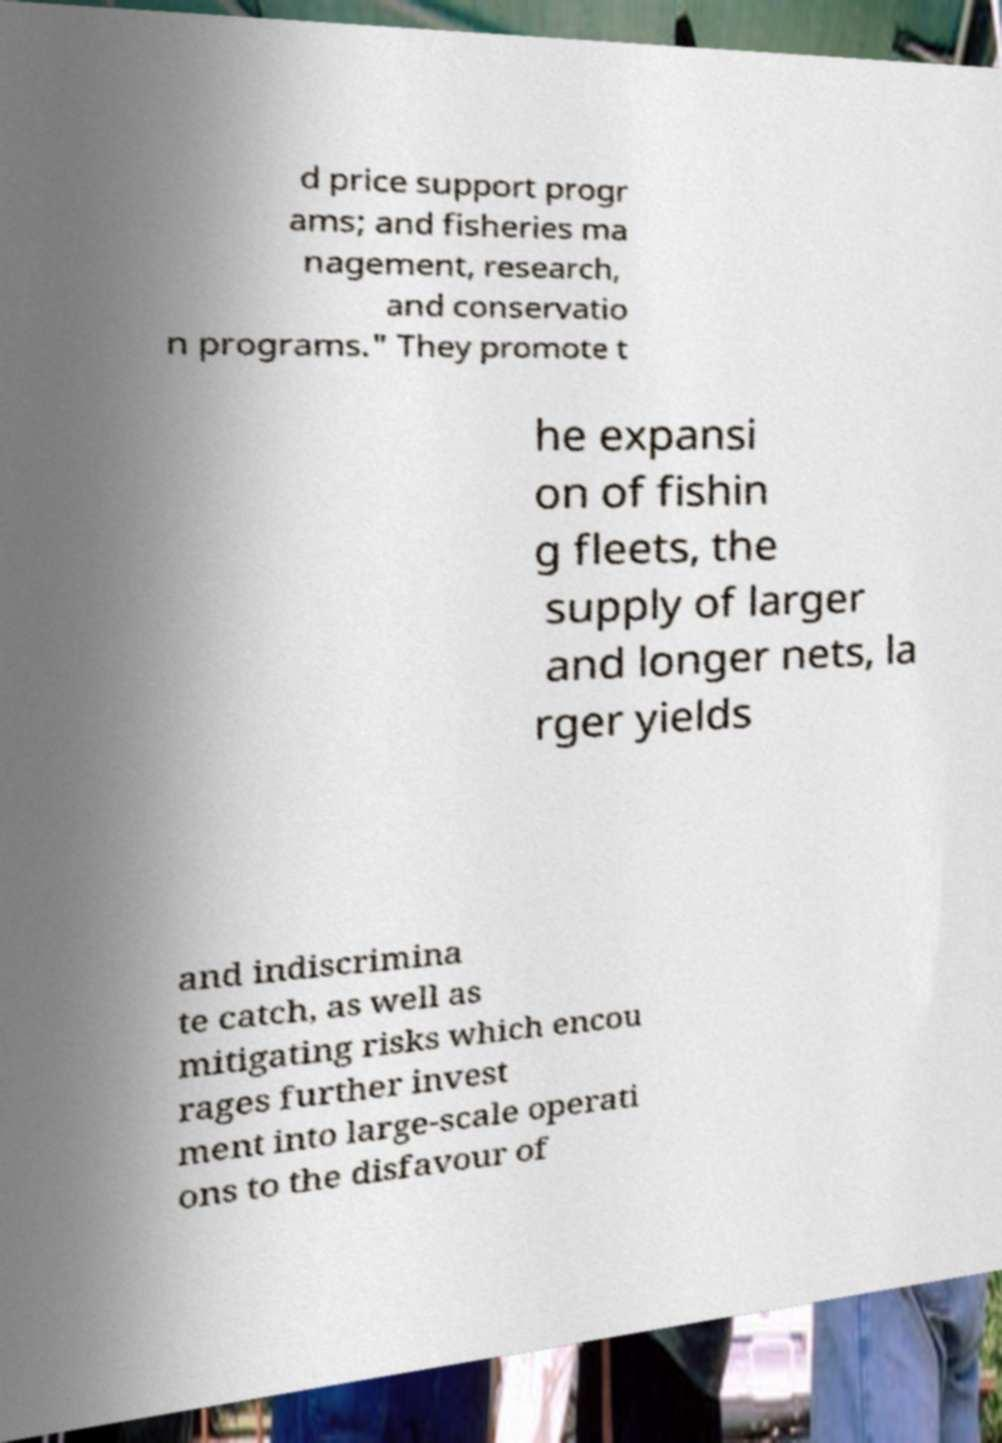Please identify and transcribe the text found in this image. d price support progr ams; and fisheries ma nagement, research, and conservatio n programs." They promote t he expansi on of fishin g fleets, the supply of larger and longer nets, la rger yields and indiscrimina te catch, as well as mitigating risks which encou rages further invest ment into large-scale operati ons to the disfavour of 